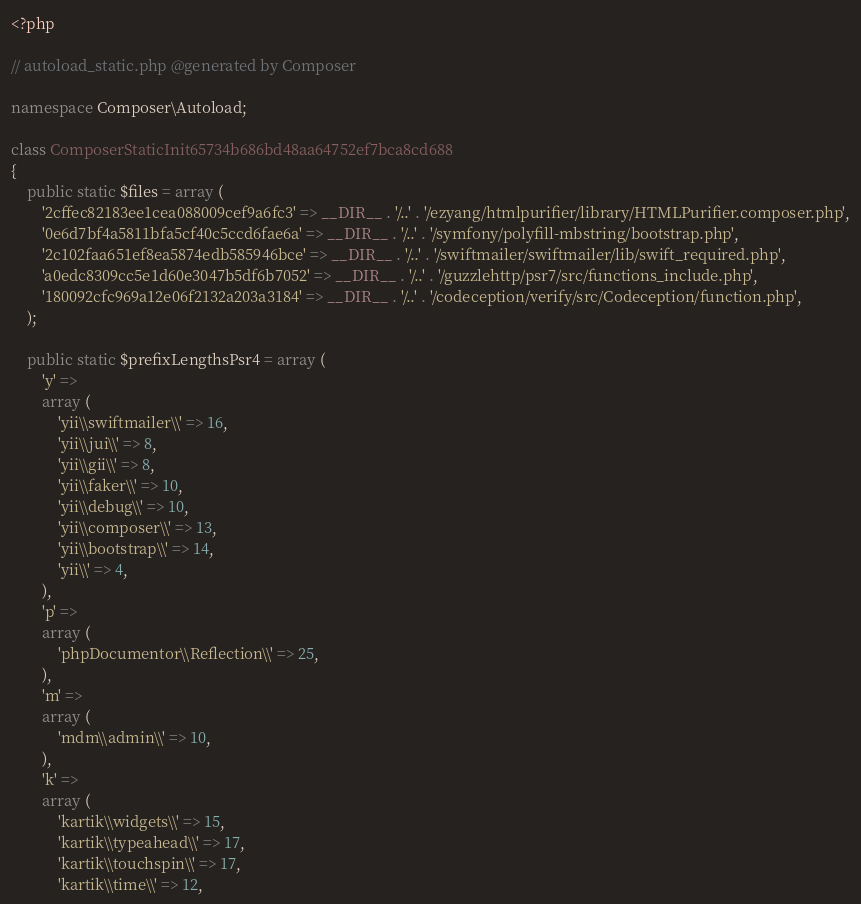<code> <loc_0><loc_0><loc_500><loc_500><_PHP_><?php

// autoload_static.php @generated by Composer

namespace Composer\Autoload;

class ComposerStaticInit65734b686bd48aa64752ef7bca8cd688
{
    public static $files = array (
        '2cffec82183ee1cea088009cef9a6fc3' => __DIR__ . '/..' . '/ezyang/htmlpurifier/library/HTMLPurifier.composer.php',
        '0e6d7bf4a5811bfa5cf40c5ccd6fae6a' => __DIR__ . '/..' . '/symfony/polyfill-mbstring/bootstrap.php',
        '2c102faa651ef8ea5874edb585946bce' => __DIR__ . '/..' . '/swiftmailer/swiftmailer/lib/swift_required.php',
        'a0edc8309cc5e1d60e3047b5df6b7052' => __DIR__ . '/..' . '/guzzlehttp/psr7/src/functions_include.php',
        '180092cfc969a12e06f2132a203a3184' => __DIR__ . '/..' . '/codeception/verify/src/Codeception/function.php',
    );

    public static $prefixLengthsPsr4 = array (
        'y' => 
        array (
            'yii\\swiftmailer\\' => 16,
            'yii\\jui\\' => 8,
            'yii\\gii\\' => 8,
            'yii\\faker\\' => 10,
            'yii\\debug\\' => 10,
            'yii\\composer\\' => 13,
            'yii\\bootstrap\\' => 14,
            'yii\\' => 4,
        ),
        'p' => 
        array (
            'phpDocumentor\\Reflection\\' => 25,
        ),
        'm' => 
        array (
            'mdm\\admin\\' => 10,
        ),
        'k' => 
        array (
            'kartik\\widgets\\' => 15,
            'kartik\\typeahead\\' => 17,
            'kartik\\touchspin\\' => 17,
            'kartik\\time\\' => 12,</code> 